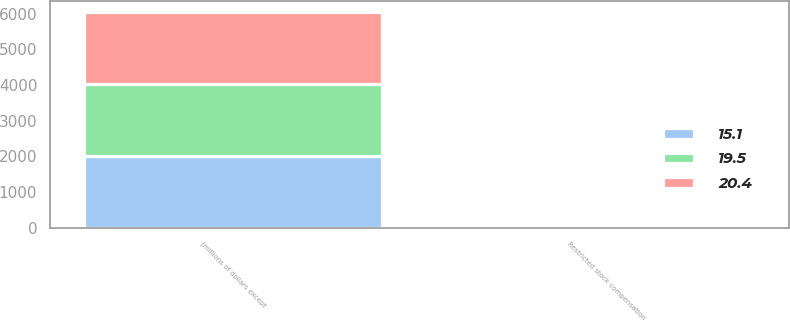Convert chart. <chart><loc_0><loc_0><loc_500><loc_500><stacked_bar_chart><ecel><fcel>(millions of dollars except<fcel>Restricted stock compensation<nl><fcel>20.4<fcel>2016<fcel>19.5<nl><fcel>19.5<fcel>2015<fcel>20.4<nl><fcel>15.1<fcel>2014<fcel>15.1<nl></chart> 